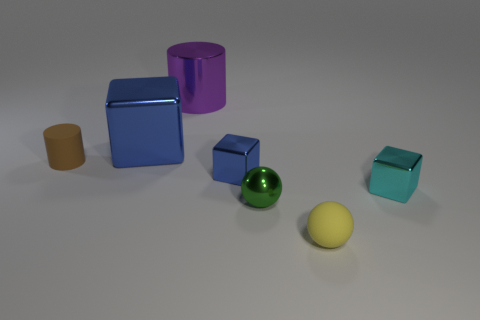How many other objects are the same color as the large block?
Ensure brevity in your answer.  1. Is the shape of the green metal object the same as the purple object?
Ensure brevity in your answer.  No. What size is the yellow object that is the same shape as the green metal thing?
Your response must be concise. Small. What number of brown things have the same material as the large cylinder?
Keep it short and to the point. 0. How many things are small cyan metallic cubes or yellow objects?
Your answer should be very brief. 2. Is there a brown object that is right of the sphere that is behind the matte ball?
Provide a succinct answer. No. Is the number of cylinders that are to the left of the green shiny ball greater than the number of tiny cyan shiny cubes that are to the left of the cyan block?
Provide a succinct answer. Yes. What number of tiny spheres have the same color as the rubber cylinder?
Offer a very short reply. 0. There is a cube that is behind the small brown rubber cylinder; is it the same color as the small metal cube left of the tiny yellow ball?
Provide a succinct answer. Yes. There is a small brown rubber cylinder; are there any things behind it?
Give a very brief answer. Yes. 